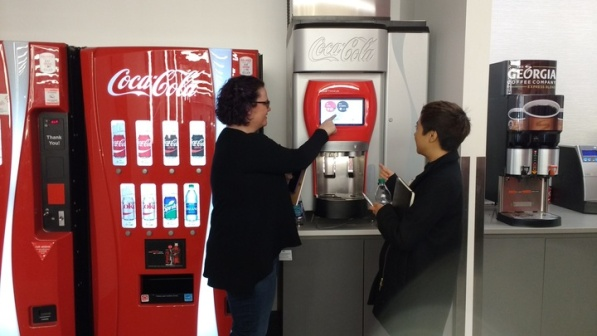What might the presence of both types of machines signify about this location? The presence of both an older button-operated machine and a newer touchscreen model in the same location likely indicates a transitionary phase where technology is being updated but older systems are still in use to accommodate all preferences and functionalities. This setting could be a public space like a community center, airport, or educational institution where a wide range of users, including those who are less tech-savvy, might interact with vending machines. It speaks to the inclusivity of the venue, ensuring accessibility and convenience for all users by providing both traditional and modern amenities. 